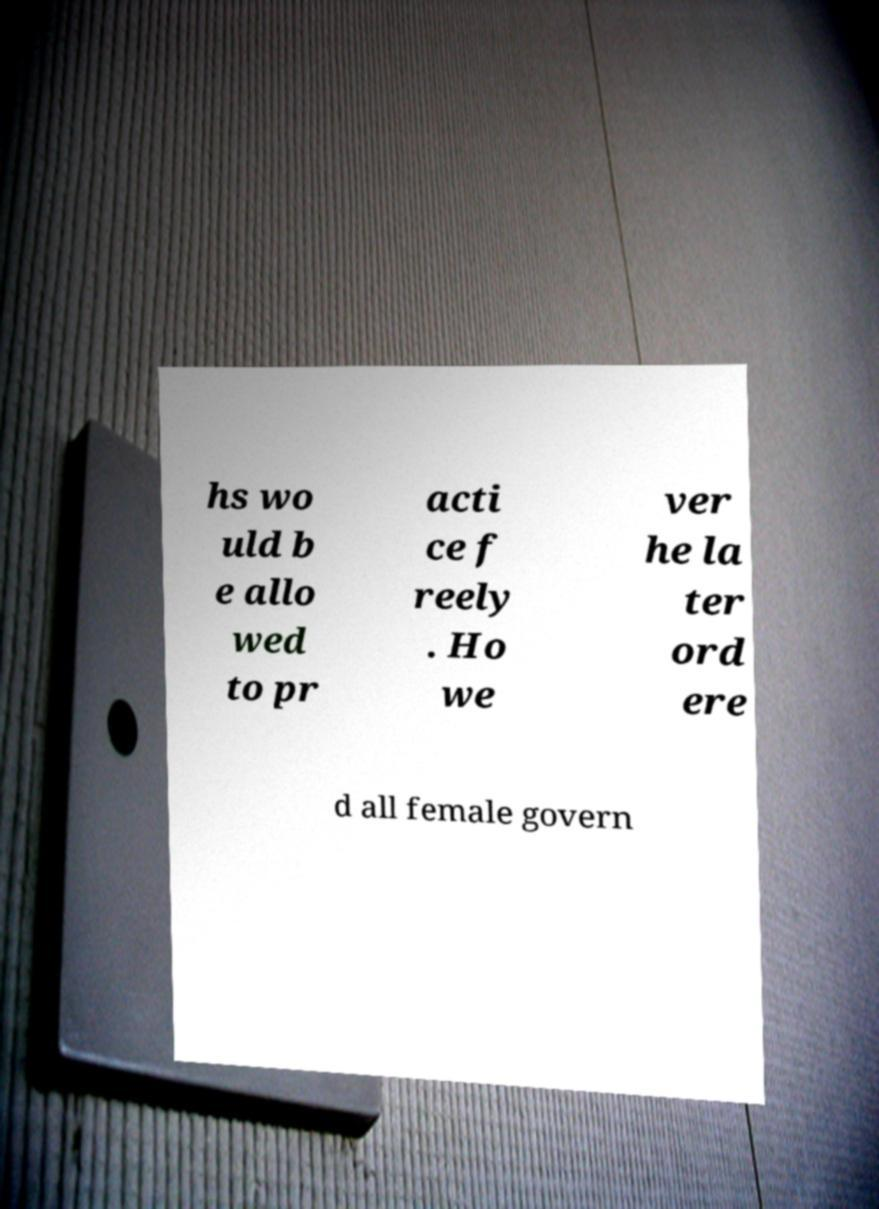There's text embedded in this image that I need extracted. Can you transcribe it verbatim? hs wo uld b e allo wed to pr acti ce f reely . Ho we ver he la ter ord ere d all female govern 